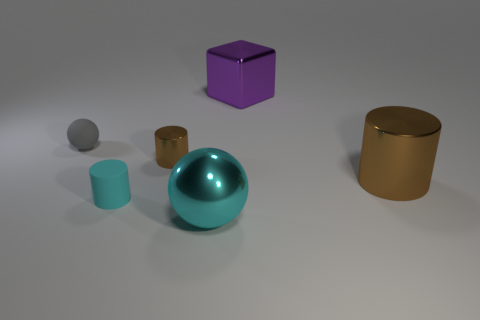Could you describe the colors and materials of the objects in the image? Certainly! In the image, there are six objects each with distinct colors and apparent materials. Starting from the left, the first is a small gray sphere that appears to be made of rubber. Next is a purple cube with a matte surface, then a small teal cylinder also with a matte finish. The largest object is a teal sphere with a shiny, reflective surface, possibly a polished metal or plastic. In the background, there's a big brown cylinder with a metallic sheen, and to its right, a smaller orange cylinder, seemingly composed of a similar metallic material as the brown one. 